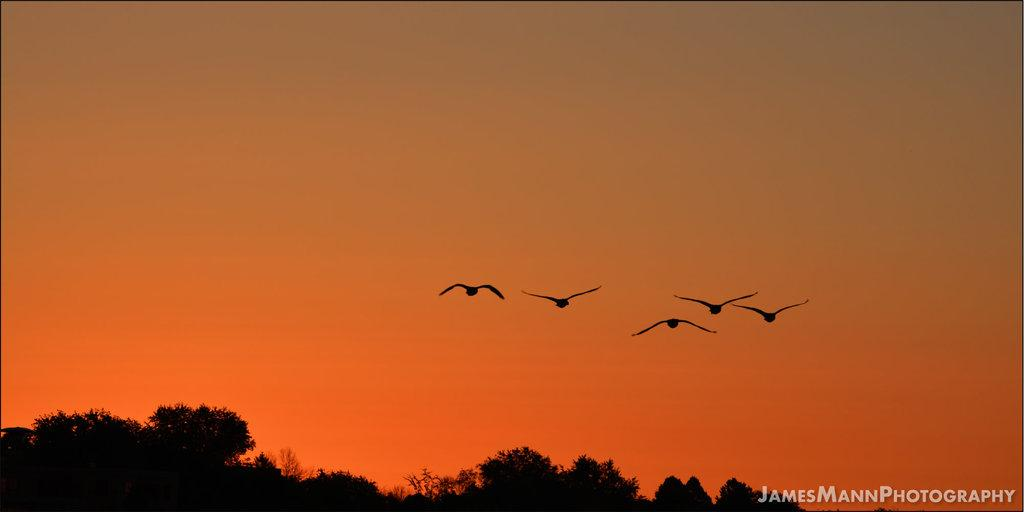What is the main subject of the image? The main subject of the image is birds. Where are the birds located in the image? The birds are in the center of the image. What else can be seen in the image besides the birds? There are trees in the image. What is visible in the background of the image? The sky is visible in the background of the image. How many seats are available for the birds in the image? There are no seats present in the image, as it features birds in a natural setting. 